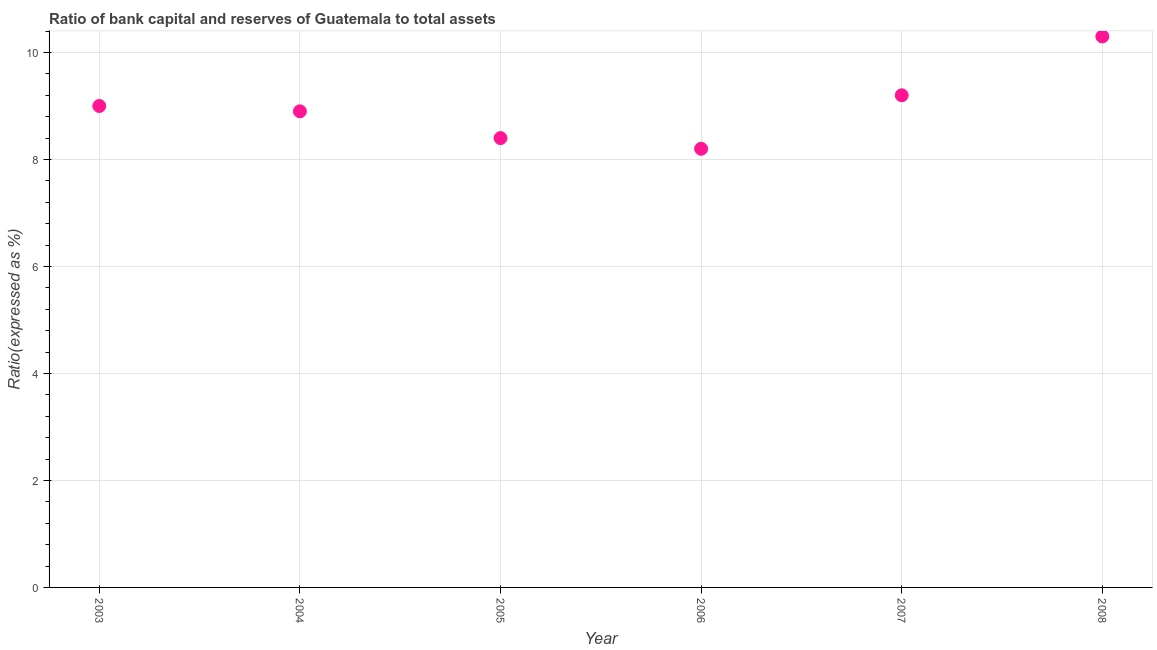In which year was the bank capital to assets ratio minimum?
Keep it short and to the point. 2006. What is the sum of the bank capital to assets ratio?
Keep it short and to the point. 54. What is the median bank capital to assets ratio?
Offer a terse response. 8.95. In how many years, is the bank capital to assets ratio greater than 6 %?
Your answer should be very brief. 6. Do a majority of the years between 2005 and 2006 (inclusive) have bank capital to assets ratio greater than 10 %?
Keep it short and to the point. No. What is the ratio of the bank capital to assets ratio in 2003 to that in 2007?
Provide a short and direct response. 0.98. Is the bank capital to assets ratio in 2006 less than that in 2007?
Your answer should be very brief. Yes. What is the difference between the highest and the second highest bank capital to assets ratio?
Your answer should be very brief. 1.1. What is the difference between the highest and the lowest bank capital to assets ratio?
Ensure brevity in your answer.  2.1. Does the bank capital to assets ratio monotonically increase over the years?
Offer a terse response. No. Are the values on the major ticks of Y-axis written in scientific E-notation?
Your answer should be very brief. No. Does the graph contain any zero values?
Offer a very short reply. No. Does the graph contain grids?
Give a very brief answer. Yes. What is the title of the graph?
Provide a succinct answer. Ratio of bank capital and reserves of Guatemala to total assets. What is the label or title of the Y-axis?
Provide a succinct answer. Ratio(expressed as %). What is the Ratio(expressed as %) in 2003?
Keep it short and to the point. 9. What is the Ratio(expressed as %) in 2006?
Offer a terse response. 8.2. What is the Ratio(expressed as %) in 2007?
Offer a terse response. 9.2. What is the Ratio(expressed as %) in 2008?
Offer a terse response. 10.3. What is the difference between the Ratio(expressed as %) in 2003 and 2005?
Provide a succinct answer. 0.6. What is the difference between the Ratio(expressed as %) in 2003 and 2006?
Your answer should be very brief. 0.8. What is the difference between the Ratio(expressed as %) in 2004 and 2005?
Your answer should be very brief. 0.5. What is the difference between the Ratio(expressed as %) in 2004 and 2007?
Keep it short and to the point. -0.3. What is the difference between the Ratio(expressed as %) in 2004 and 2008?
Your answer should be compact. -1.4. What is the difference between the Ratio(expressed as %) in 2005 and 2006?
Your answer should be compact. 0.2. What is the difference between the Ratio(expressed as %) in 2006 and 2007?
Your answer should be very brief. -1. What is the difference between the Ratio(expressed as %) in 2006 and 2008?
Provide a short and direct response. -2.1. What is the difference between the Ratio(expressed as %) in 2007 and 2008?
Your answer should be compact. -1.1. What is the ratio of the Ratio(expressed as %) in 2003 to that in 2004?
Offer a very short reply. 1.01. What is the ratio of the Ratio(expressed as %) in 2003 to that in 2005?
Keep it short and to the point. 1.07. What is the ratio of the Ratio(expressed as %) in 2003 to that in 2006?
Give a very brief answer. 1.1. What is the ratio of the Ratio(expressed as %) in 2003 to that in 2008?
Your answer should be very brief. 0.87. What is the ratio of the Ratio(expressed as %) in 2004 to that in 2005?
Offer a very short reply. 1.06. What is the ratio of the Ratio(expressed as %) in 2004 to that in 2006?
Offer a very short reply. 1.08. What is the ratio of the Ratio(expressed as %) in 2004 to that in 2008?
Give a very brief answer. 0.86. What is the ratio of the Ratio(expressed as %) in 2005 to that in 2008?
Keep it short and to the point. 0.82. What is the ratio of the Ratio(expressed as %) in 2006 to that in 2007?
Ensure brevity in your answer.  0.89. What is the ratio of the Ratio(expressed as %) in 2006 to that in 2008?
Offer a very short reply. 0.8. What is the ratio of the Ratio(expressed as %) in 2007 to that in 2008?
Offer a very short reply. 0.89. 